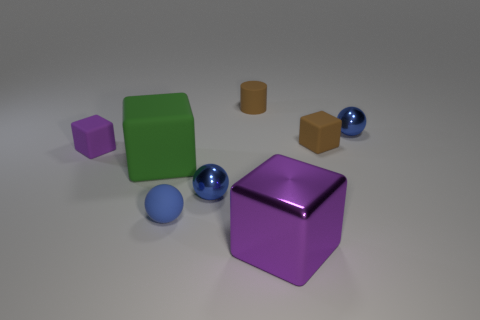Subtract all yellow spheres. How many purple blocks are left? 2 Subtract all matte spheres. How many spheres are left? 2 Subtract all brown cubes. How many cubes are left? 3 Add 1 small purple rubber cylinders. How many objects exist? 9 Subtract all balls. How many objects are left? 5 Subtract all gray spheres. Subtract all purple blocks. How many spheres are left? 3 Subtract 0 yellow cylinders. How many objects are left? 8 Subtract all small cubes. Subtract all green things. How many objects are left? 5 Add 2 blue metallic objects. How many blue metallic objects are left? 4 Add 7 tiny purple objects. How many tiny purple objects exist? 8 